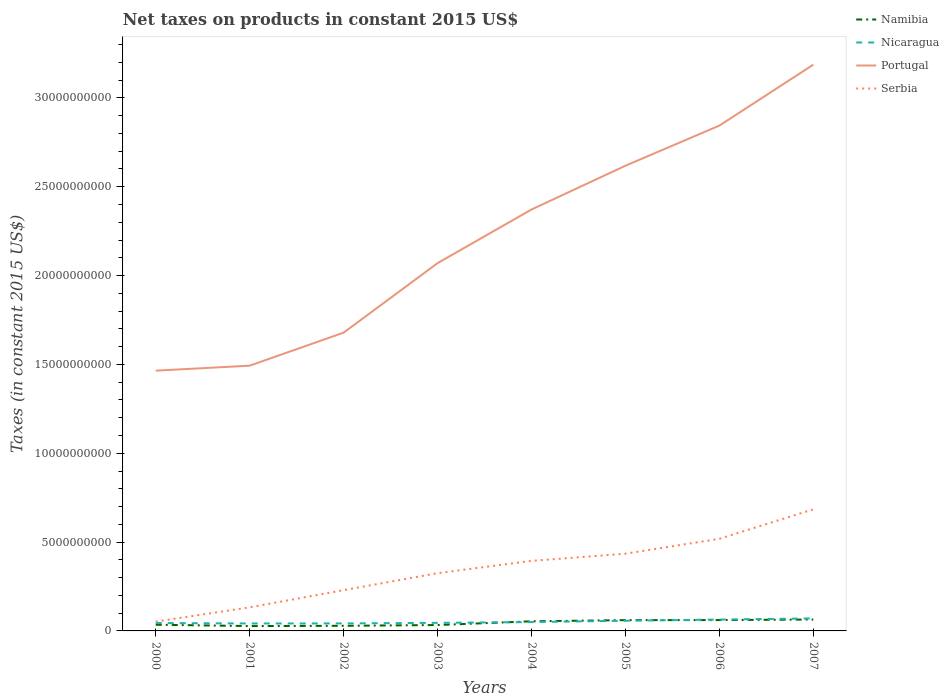How many different coloured lines are there?
Make the answer very short. 4. Is the number of lines equal to the number of legend labels?
Provide a short and direct response. Yes. Across all years, what is the maximum net taxes on products in Nicaragua?
Give a very brief answer. 4.19e+08. In which year was the net taxes on products in Namibia maximum?
Give a very brief answer. 2001. What is the total net taxes on products in Serbia in the graph?
Your answer should be compact. -1.10e+09. What is the difference between the highest and the second highest net taxes on products in Namibia?
Offer a terse response. 3.68e+08. What is the difference between the highest and the lowest net taxes on products in Nicaragua?
Provide a succinct answer. 3. What is the difference between two consecutive major ticks on the Y-axis?
Offer a terse response. 5.00e+09. Does the graph contain any zero values?
Offer a very short reply. No. Does the graph contain grids?
Your answer should be very brief. No. Where does the legend appear in the graph?
Your answer should be compact. Top right. How many legend labels are there?
Keep it short and to the point. 4. How are the legend labels stacked?
Ensure brevity in your answer.  Vertical. What is the title of the graph?
Offer a terse response. Net taxes on products in constant 2015 US$. What is the label or title of the Y-axis?
Keep it short and to the point. Taxes (in constant 2015 US$). What is the Taxes (in constant 2015 US$) of Namibia in 2000?
Ensure brevity in your answer.  3.49e+08. What is the Taxes (in constant 2015 US$) in Nicaragua in 2000?
Give a very brief answer. 4.45e+08. What is the Taxes (in constant 2015 US$) of Portugal in 2000?
Make the answer very short. 1.46e+1. What is the Taxes (in constant 2015 US$) in Serbia in 2000?
Make the answer very short. 5.25e+08. What is the Taxes (in constant 2015 US$) in Namibia in 2001?
Make the answer very short. 2.73e+08. What is the Taxes (in constant 2015 US$) in Nicaragua in 2001?
Ensure brevity in your answer.  4.19e+08. What is the Taxes (in constant 2015 US$) of Portugal in 2001?
Provide a short and direct response. 1.49e+1. What is the Taxes (in constant 2015 US$) in Serbia in 2001?
Offer a terse response. 1.33e+09. What is the Taxes (in constant 2015 US$) in Namibia in 2002?
Provide a succinct answer. 2.88e+08. What is the Taxes (in constant 2015 US$) of Nicaragua in 2002?
Offer a terse response. 4.23e+08. What is the Taxes (in constant 2015 US$) of Portugal in 2002?
Give a very brief answer. 1.68e+1. What is the Taxes (in constant 2015 US$) of Serbia in 2002?
Your answer should be very brief. 2.29e+09. What is the Taxes (in constant 2015 US$) in Namibia in 2003?
Keep it short and to the point. 3.31e+08. What is the Taxes (in constant 2015 US$) of Nicaragua in 2003?
Your answer should be compact. 4.55e+08. What is the Taxes (in constant 2015 US$) of Portugal in 2003?
Give a very brief answer. 2.07e+1. What is the Taxes (in constant 2015 US$) of Serbia in 2003?
Offer a very short reply. 3.25e+09. What is the Taxes (in constant 2015 US$) of Namibia in 2004?
Offer a terse response. 5.42e+08. What is the Taxes (in constant 2015 US$) of Nicaragua in 2004?
Your answer should be compact. 4.97e+08. What is the Taxes (in constant 2015 US$) in Portugal in 2004?
Ensure brevity in your answer.  2.37e+1. What is the Taxes (in constant 2015 US$) in Serbia in 2004?
Your response must be concise. 3.94e+09. What is the Taxes (in constant 2015 US$) in Namibia in 2005?
Offer a terse response. 6.08e+08. What is the Taxes (in constant 2015 US$) in Nicaragua in 2005?
Offer a terse response. 5.73e+08. What is the Taxes (in constant 2015 US$) in Portugal in 2005?
Ensure brevity in your answer.  2.62e+1. What is the Taxes (in constant 2015 US$) of Serbia in 2005?
Your answer should be very brief. 4.35e+09. What is the Taxes (in constant 2015 US$) of Namibia in 2006?
Make the answer very short. 6.10e+08. What is the Taxes (in constant 2015 US$) of Nicaragua in 2006?
Keep it short and to the point. 6.40e+08. What is the Taxes (in constant 2015 US$) in Portugal in 2006?
Offer a terse response. 2.84e+1. What is the Taxes (in constant 2015 US$) in Serbia in 2006?
Offer a very short reply. 5.18e+09. What is the Taxes (in constant 2015 US$) in Namibia in 2007?
Offer a very short reply. 6.42e+08. What is the Taxes (in constant 2015 US$) of Nicaragua in 2007?
Your answer should be very brief. 7.04e+08. What is the Taxes (in constant 2015 US$) of Portugal in 2007?
Your answer should be very brief. 3.19e+1. What is the Taxes (in constant 2015 US$) in Serbia in 2007?
Your response must be concise. 6.84e+09. Across all years, what is the maximum Taxes (in constant 2015 US$) of Namibia?
Give a very brief answer. 6.42e+08. Across all years, what is the maximum Taxes (in constant 2015 US$) of Nicaragua?
Your response must be concise. 7.04e+08. Across all years, what is the maximum Taxes (in constant 2015 US$) in Portugal?
Your response must be concise. 3.19e+1. Across all years, what is the maximum Taxes (in constant 2015 US$) in Serbia?
Provide a succinct answer. 6.84e+09. Across all years, what is the minimum Taxes (in constant 2015 US$) of Namibia?
Keep it short and to the point. 2.73e+08. Across all years, what is the minimum Taxes (in constant 2015 US$) in Nicaragua?
Offer a terse response. 4.19e+08. Across all years, what is the minimum Taxes (in constant 2015 US$) in Portugal?
Ensure brevity in your answer.  1.46e+1. Across all years, what is the minimum Taxes (in constant 2015 US$) of Serbia?
Your answer should be very brief. 5.25e+08. What is the total Taxes (in constant 2015 US$) of Namibia in the graph?
Offer a terse response. 3.64e+09. What is the total Taxes (in constant 2015 US$) of Nicaragua in the graph?
Make the answer very short. 4.16e+09. What is the total Taxes (in constant 2015 US$) in Portugal in the graph?
Your answer should be compact. 1.77e+11. What is the total Taxes (in constant 2015 US$) of Serbia in the graph?
Provide a short and direct response. 2.77e+1. What is the difference between the Taxes (in constant 2015 US$) of Namibia in 2000 and that in 2001?
Give a very brief answer. 7.55e+07. What is the difference between the Taxes (in constant 2015 US$) of Nicaragua in 2000 and that in 2001?
Provide a short and direct response. 2.55e+07. What is the difference between the Taxes (in constant 2015 US$) in Portugal in 2000 and that in 2001?
Your response must be concise. -2.81e+08. What is the difference between the Taxes (in constant 2015 US$) of Serbia in 2000 and that in 2001?
Your response must be concise. -8.02e+08. What is the difference between the Taxes (in constant 2015 US$) of Namibia in 2000 and that in 2002?
Ensure brevity in your answer.  6.06e+07. What is the difference between the Taxes (in constant 2015 US$) in Nicaragua in 2000 and that in 2002?
Your answer should be compact. 2.14e+07. What is the difference between the Taxes (in constant 2015 US$) in Portugal in 2000 and that in 2002?
Offer a terse response. -2.14e+09. What is the difference between the Taxes (in constant 2015 US$) in Serbia in 2000 and that in 2002?
Your response must be concise. -1.77e+09. What is the difference between the Taxes (in constant 2015 US$) of Namibia in 2000 and that in 2003?
Provide a succinct answer. 1.76e+07. What is the difference between the Taxes (in constant 2015 US$) of Nicaragua in 2000 and that in 2003?
Offer a very short reply. -9.90e+06. What is the difference between the Taxes (in constant 2015 US$) of Portugal in 2000 and that in 2003?
Ensure brevity in your answer.  -6.05e+09. What is the difference between the Taxes (in constant 2015 US$) in Serbia in 2000 and that in 2003?
Provide a short and direct response. -2.73e+09. What is the difference between the Taxes (in constant 2015 US$) of Namibia in 2000 and that in 2004?
Make the answer very short. -1.93e+08. What is the difference between the Taxes (in constant 2015 US$) in Nicaragua in 2000 and that in 2004?
Keep it short and to the point. -5.20e+07. What is the difference between the Taxes (in constant 2015 US$) of Portugal in 2000 and that in 2004?
Give a very brief answer. -9.07e+09. What is the difference between the Taxes (in constant 2015 US$) of Serbia in 2000 and that in 2004?
Make the answer very short. -3.42e+09. What is the difference between the Taxes (in constant 2015 US$) of Namibia in 2000 and that in 2005?
Provide a succinct answer. -2.59e+08. What is the difference between the Taxes (in constant 2015 US$) in Nicaragua in 2000 and that in 2005?
Keep it short and to the point. -1.28e+08. What is the difference between the Taxes (in constant 2015 US$) in Portugal in 2000 and that in 2005?
Keep it short and to the point. -1.15e+1. What is the difference between the Taxes (in constant 2015 US$) in Serbia in 2000 and that in 2005?
Offer a very short reply. -3.82e+09. What is the difference between the Taxes (in constant 2015 US$) of Namibia in 2000 and that in 2006?
Give a very brief answer. -2.62e+08. What is the difference between the Taxes (in constant 2015 US$) in Nicaragua in 2000 and that in 2006?
Make the answer very short. -1.96e+08. What is the difference between the Taxes (in constant 2015 US$) of Portugal in 2000 and that in 2006?
Provide a short and direct response. -1.38e+1. What is the difference between the Taxes (in constant 2015 US$) in Serbia in 2000 and that in 2006?
Keep it short and to the point. -4.66e+09. What is the difference between the Taxes (in constant 2015 US$) of Namibia in 2000 and that in 2007?
Give a very brief answer. -2.93e+08. What is the difference between the Taxes (in constant 2015 US$) of Nicaragua in 2000 and that in 2007?
Offer a very short reply. -2.59e+08. What is the difference between the Taxes (in constant 2015 US$) of Portugal in 2000 and that in 2007?
Make the answer very short. -1.72e+1. What is the difference between the Taxes (in constant 2015 US$) of Serbia in 2000 and that in 2007?
Your response must be concise. -6.32e+09. What is the difference between the Taxes (in constant 2015 US$) in Namibia in 2001 and that in 2002?
Ensure brevity in your answer.  -1.49e+07. What is the difference between the Taxes (in constant 2015 US$) in Nicaragua in 2001 and that in 2002?
Offer a terse response. -4.11e+06. What is the difference between the Taxes (in constant 2015 US$) in Portugal in 2001 and that in 2002?
Give a very brief answer. -1.86e+09. What is the difference between the Taxes (in constant 2015 US$) in Serbia in 2001 and that in 2002?
Provide a short and direct response. -9.67e+08. What is the difference between the Taxes (in constant 2015 US$) in Namibia in 2001 and that in 2003?
Provide a succinct answer. -5.79e+07. What is the difference between the Taxes (in constant 2015 US$) of Nicaragua in 2001 and that in 2003?
Ensure brevity in your answer.  -3.54e+07. What is the difference between the Taxes (in constant 2015 US$) in Portugal in 2001 and that in 2003?
Keep it short and to the point. -5.77e+09. What is the difference between the Taxes (in constant 2015 US$) in Serbia in 2001 and that in 2003?
Offer a terse response. -1.92e+09. What is the difference between the Taxes (in constant 2015 US$) in Namibia in 2001 and that in 2004?
Your answer should be compact. -2.69e+08. What is the difference between the Taxes (in constant 2015 US$) in Nicaragua in 2001 and that in 2004?
Offer a terse response. -7.75e+07. What is the difference between the Taxes (in constant 2015 US$) in Portugal in 2001 and that in 2004?
Your answer should be very brief. -8.79e+09. What is the difference between the Taxes (in constant 2015 US$) of Serbia in 2001 and that in 2004?
Provide a short and direct response. -2.62e+09. What is the difference between the Taxes (in constant 2015 US$) of Namibia in 2001 and that in 2005?
Your answer should be compact. -3.34e+08. What is the difference between the Taxes (in constant 2015 US$) in Nicaragua in 2001 and that in 2005?
Offer a terse response. -1.54e+08. What is the difference between the Taxes (in constant 2015 US$) in Portugal in 2001 and that in 2005?
Provide a short and direct response. -1.13e+1. What is the difference between the Taxes (in constant 2015 US$) of Serbia in 2001 and that in 2005?
Offer a terse response. -3.02e+09. What is the difference between the Taxes (in constant 2015 US$) in Namibia in 2001 and that in 2006?
Provide a short and direct response. -3.37e+08. What is the difference between the Taxes (in constant 2015 US$) of Nicaragua in 2001 and that in 2006?
Provide a short and direct response. -2.21e+08. What is the difference between the Taxes (in constant 2015 US$) in Portugal in 2001 and that in 2006?
Offer a very short reply. -1.35e+1. What is the difference between the Taxes (in constant 2015 US$) in Serbia in 2001 and that in 2006?
Make the answer very short. -3.86e+09. What is the difference between the Taxes (in constant 2015 US$) in Namibia in 2001 and that in 2007?
Provide a short and direct response. -3.68e+08. What is the difference between the Taxes (in constant 2015 US$) of Nicaragua in 2001 and that in 2007?
Offer a terse response. -2.85e+08. What is the difference between the Taxes (in constant 2015 US$) of Portugal in 2001 and that in 2007?
Offer a terse response. -1.69e+1. What is the difference between the Taxes (in constant 2015 US$) in Serbia in 2001 and that in 2007?
Offer a terse response. -5.52e+09. What is the difference between the Taxes (in constant 2015 US$) of Namibia in 2002 and that in 2003?
Give a very brief answer. -4.30e+07. What is the difference between the Taxes (in constant 2015 US$) of Nicaragua in 2002 and that in 2003?
Provide a short and direct response. -3.13e+07. What is the difference between the Taxes (in constant 2015 US$) of Portugal in 2002 and that in 2003?
Give a very brief answer. -3.91e+09. What is the difference between the Taxes (in constant 2015 US$) of Serbia in 2002 and that in 2003?
Provide a succinct answer. -9.57e+08. What is the difference between the Taxes (in constant 2015 US$) in Namibia in 2002 and that in 2004?
Offer a very short reply. -2.54e+08. What is the difference between the Taxes (in constant 2015 US$) of Nicaragua in 2002 and that in 2004?
Offer a very short reply. -7.34e+07. What is the difference between the Taxes (in constant 2015 US$) in Portugal in 2002 and that in 2004?
Offer a very short reply. -6.93e+09. What is the difference between the Taxes (in constant 2015 US$) in Serbia in 2002 and that in 2004?
Your answer should be compact. -1.65e+09. What is the difference between the Taxes (in constant 2015 US$) in Namibia in 2002 and that in 2005?
Your answer should be compact. -3.19e+08. What is the difference between the Taxes (in constant 2015 US$) in Nicaragua in 2002 and that in 2005?
Offer a very short reply. -1.50e+08. What is the difference between the Taxes (in constant 2015 US$) in Portugal in 2002 and that in 2005?
Make the answer very short. -9.39e+09. What is the difference between the Taxes (in constant 2015 US$) of Serbia in 2002 and that in 2005?
Provide a short and direct response. -2.05e+09. What is the difference between the Taxes (in constant 2015 US$) of Namibia in 2002 and that in 2006?
Keep it short and to the point. -3.22e+08. What is the difference between the Taxes (in constant 2015 US$) in Nicaragua in 2002 and that in 2006?
Your answer should be compact. -2.17e+08. What is the difference between the Taxes (in constant 2015 US$) of Portugal in 2002 and that in 2006?
Your answer should be very brief. -1.17e+1. What is the difference between the Taxes (in constant 2015 US$) in Serbia in 2002 and that in 2006?
Your response must be concise. -2.89e+09. What is the difference between the Taxes (in constant 2015 US$) in Namibia in 2002 and that in 2007?
Make the answer very short. -3.54e+08. What is the difference between the Taxes (in constant 2015 US$) of Nicaragua in 2002 and that in 2007?
Provide a succinct answer. -2.81e+08. What is the difference between the Taxes (in constant 2015 US$) in Portugal in 2002 and that in 2007?
Your response must be concise. -1.51e+1. What is the difference between the Taxes (in constant 2015 US$) of Serbia in 2002 and that in 2007?
Keep it short and to the point. -4.55e+09. What is the difference between the Taxes (in constant 2015 US$) of Namibia in 2003 and that in 2004?
Ensure brevity in your answer.  -2.11e+08. What is the difference between the Taxes (in constant 2015 US$) of Nicaragua in 2003 and that in 2004?
Ensure brevity in your answer.  -4.21e+07. What is the difference between the Taxes (in constant 2015 US$) of Portugal in 2003 and that in 2004?
Your response must be concise. -3.02e+09. What is the difference between the Taxes (in constant 2015 US$) of Serbia in 2003 and that in 2004?
Offer a terse response. -6.91e+08. What is the difference between the Taxes (in constant 2015 US$) of Namibia in 2003 and that in 2005?
Offer a very short reply. -2.76e+08. What is the difference between the Taxes (in constant 2015 US$) in Nicaragua in 2003 and that in 2005?
Give a very brief answer. -1.18e+08. What is the difference between the Taxes (in constant 2015 US$) of Portugal in 2003 and that in 2005?
Ensure brevity in your answer.  -5.48e+09. What is the difference between the Taxes (in constant 2015 US$) in Serbia in 2003 and that in 2005?
Provide a short and direct response. -1.10e+09. What is the difference between the Taxes (in constant 2015 US$) of Namibia in 2003 and that in 2006?
Provide a short and direct response. -2.79e+08. What is the difference between the Taxes (in constant 2015 US$) of Nicaragua in 2003 and that in 2006?
Ensure brevity in your answer.  -1.86e+08. What is the difference between the Taxes (in constant 2015 US$) in Portugal in 2003 and that in 2006?
Provide a succinct answer. -7.74e+09. What is the difference between the Taxes (in constant 2015 US$) in Serbia in 2003 and that in 2006?
Ensure brevity in your answer.  -1.93e+09. What is the difference between the Taxes (in constant 2015 US$) in Namibia in 2003 and that in 2007?
Keep it short and to the point. -3.11e+08. What is the difference between the Taxes (in constant 2015 US$) in Nicaragua in 2003 and that in 2007?
Ensure brevity in your answer.  -2.49e+08. What is the difference between the Taxes (in constant 2015 US$) of Portugal in 2003 and that in 2007?
Offer a terse response. -1.12e+1. What is the difference between the Taxes (in constant 2015 US$) of Serbia in 2003 and that in 2007?
Ensure brevity in your answer.  -3.59e+09. What is the difference between the Taxes (in constant 2015 US$) in Namibia in 2004 and that in 2005?
Make the answer very short. -6.54e+07. What is the difference between the Taxes (in constant 2015 US$) in Nicaragua in 2004 and that in 2005?
Your response must be concise. -7.62e+07. What is the difference between the Taxes (in constant 2015 US$) of Portugal in 2004 and that in 2005?
Ensure brevity in your answer.  -2.47e+09. What is the difference between the Taxes (in constant 2015 US$) of Serbia in 2004 and that in 2005?
Ensure brevity in your answer.  -4.05e+08. What is the difference between the Taxes (in constant 2015 US$) of Namibia in 2004 and that in 2006?
Offer a very short reply. -6.82e+07. What is the difference between the Taxes (in constant 2015 US$) of Nicaragua in 2004 and that in 2006?
Give a very brief answer. -1.43e+08. What is the difference between the Taxes (in constant 2015 US$) in Portugal in 2004 and that in 2006?
Provide a short and direct response. -4.72e+09. What is the difference between the Taxes (in constant 2015 US$) in Serbia in 2004 and that in 2006?
Offer a very short reply. -1.24e+09. What is the difference between the Taxes (in constant 2015 US$) of Namibia in 2004 and that in 2007?
Provide a succinct answer. -9.96e+07. What is the difference between the Taxes (in constant 2015 US$) in Nicaragua in 2004 and that in 2007?
Ensure brevity in your answer.  -2.07e+08. What is the difference between the Taxes (in constant 2015 US$) in Portugal in 2004 and that in 2007?
Your answer should be compact. -8.15e+09. What is the difference between the Taxes (in constant 2015 US$) of Serbia in 2004 and that in 2007?
Offer a very short reply. -2.90e+09. What is the difference between the Taxes (in constant 2015 US$) of Namibia in 2005 and that in 2006?
Your response must be concise. -2.85e+06. What is the difference between the Taxes (in constant 2015 US$) in Nicaragua in 2005 and that in 2006?
Offer a very short reply. -6.73e+07. What is the difference between the Taxes (in constant 2015 US$) in Portugal in 2005 and that in 2006?
Provide a succinct answer. -2.26e+09. What is the difference between the Taxes (in constant 2015 US$) of Serbia in 2005 and that in 2006?
Provide a short and direct response. -8.37e+08. What is the difference between the Taxes (in constant 2015 US$) in Namibia in 2005 and that in 2007?
Ensure brevity in your answer.  -3.43e+07. What is the difference between the Taxes (in constant 2015 US$) of Nicaragua in 2005 and that in 2007?
Give a very brief answer. -1.31e+08. What is the difference between the Taxes (in constant 2015 US$) in Portugal in 2005 and that in 2007?
Your response must be concise. -5.69e+09. What is the difference between the Taxes (in constant 2015 US$) in Serbia in 2005 and that in 2007?
Provide a succinct answer. -2.50e+09. What is the difference between the Taxes (in constant 2015 US$) of Namibia in 2006 and that in 2007?
Offer a very short reply. -3.14e+07. What is the difference between the Taxes (in constant 2015 US$) of Nicaragua in 2006 and that in 2007?
Keep it short and to the point. -6.38e+07. What is the difference between the Taxes (in constant 2015 US$) of Portugal in 2006 and that in 2007?
Provide a succinct answer. -3.43e+09. What is the difference between the Taxes (in constant 2015 US$) of Serbia in 2006 and that in 2007?
Ensure brevity in your answer.  -1.66e+09. What is the difference between the Taxes (in constant 2015 US$) of Namibia in 2000 and the Taxes (in constant 2015 US$) of Nicaragua in 2001?
Offer a very short reply. -7.03e+07. What is the difference between the Taxes (in constant 2015 US$) in Namibia in 2000 and the Taxes (in constant 2015 US$) in Portugal in 2001?
Offer a very short reply. -1.46e+1. What is the difference between the Taxes (in constant 2015 US$) in Namibia in 2000 and the Taxes (in constant 2015 US$) in Serbia in 2001?
Offer a very short reply. -9.78e+08. What is the difference between the Taxes (in constant 2015 US$) in Nicaragua in 2000 and the Taxes (in constant 2015 US$) in Portugal in 2001?
Provide a short and direct response. -1.45e+1. What is the difference between the Taxes (in constant 2015 US$) in Nicaragua in 2000 and the Taxes (in constant 2015 US$) in Serbia in 2001?
Make the answer very short. -8.82e+08. What is the difference between the Taxes (in constant 2015 US$) of Portugal in 2000 and the Taxes (in constant 2015 US$) of Serbia in 2001?
Offer a terse response. 1.33e+1. What is the difference between the Taxes (in constant 2015 US$) in Namibia in 2000 and the Taxes (in constant 2015 US$) in Nicaragua in 2002?
Your answer should be compact. -7.44e+07. What is the difference between the Taxes (in constant 2015 US$) of Namibia in 2000 and the Taxes (in constant 2015 US$) of Portugal in 2002?
Your answer should be compact. -1.64e+1. What is the difference between the Taxes (in constant 2015 US$) of Namibia in 2000 and the Taxes (in constant 2015 US$) of Serbia in 2002?
Your answer should be very brief. -1.95e+09. What is the difference between the Taxes (in constant 2015 US$) in Nicaragua in 2000 and the Taxes (in constant 2015 US$) in Portugal in 2002?
Offer a terse response. -1.63e+1. What is the difference between the Taxes (in constant 2015 US$) of Nicaragua in 2000 and the Taxes (in constant 2015 US$) of Serbia in 2002?
Provide a short and direct response. -1.85e+09. What is the difference between the Taxes (in constant 2015 US$) of Portugal in 2000 and the Taxes (in constant 2015 US$) of Serbia in 2002?
Your answer should be compact. 1.24e+1. What is the difference between the Taxes (in constant 2015 US$) in Namibia in 2000 and the Taxes (in constant 2015 US$) in Nicaragua in 2003?
Offer a terse response. -1.06e+08. What is the difference between the Taxes (in constant 2015 US$) in Namibia in 2000 and the Taxes (in constant 2015 US$) in Portugal in 2003?
Offer a terse response. -2.04e+1. What is the difference between the Taxes (in constant 2015 US$) of Namibia in 2000 and the Taxes (in constant 2015 US$) of Serbia in 2003?
Your answer should be very brief. -2.90e+09. What is the difference between the Taxes (in constant 2015 US$) of Nicaragua in 2000 and the Taxes (in constant 2015 US$) of Portugal in 2003?
Provide a short and direct response. -2.03e+1. What is the difference between the Taxes (in constant 2015 US$) of Nicaragua in 2000 and the Taxes (in constant 2015 US$) of Serbia in 2003?
Your response must be concise. -2.81e+09. What is the difference between the Taxes (in constant 2015 US$) in Portugal in 2000 and the Taxes (in constant 2015 US$) in Serbia in 2003?
Offer a very short reply. 1.14e+1. What is the difference between the Taxes (in constant 2015 US$) of Namibia in 2000 and the Taxes (in constant 2015 US$) of Nicaragua in 2004?
Make the answer very short. -1.48e+08. What is the difference between the Taxes (in constant 2015 US$) in Namibia in 2000 and the Taxes (in constant 2015 US$) in Portugal in 2004?
Your answer should be very brief. -2.34e+1. What is the difference between the Taxes (in constant 2015 US$) in Namibia in 2000 and the Taxes (in constant 2015 US$) in Serbia in 2004?
Your response must be concise. -3.59e+09. What is the difference between the Taxes (in constant 2015 US$) in Nicaragua in 2000 and the Taxes (in constant 2015 US$) in Portugal in 2004?
Your answer should be compact. -2.33e+1. What is the difference between the Taxes (in constant 2015 US$) of Nicaragua in 2000 and the Taxes (in constant 2015 US$) of Serbia in 2004?
Offer a very short reply. -3.50e+09. What is the difference between the Taxes (in constant 2015 US$) in Portugal in 2000 and the Taxes (in constant 2015 US$) in Serbia in 2004?
Keep it short and to the point. 1.07e+1. What is the difference between the Taxes (in constant 2015 US$) in Namibia in 2000 and the Taxes (in constant 2015 US$) in Nicaragua in 2005?
Your answer should be very brief. -2.24e+08. What is the difference between the Taxes (in constant 2015 US$) of Namibia in 2000 and the Taxes (in constant 2015 US$) of Portugal in 2005?
Your response must be concise. -2.58e+1. What is the difference between the Taxes (in constant 2015 US$) of Namibia in 2000 and the Taxes (in constant 2015 US$) of Serbia in 2005?
Offer a terse response. -4.00e+09. What is the difference between the Taxes (in constant 2015 US$) in Nicaragua in 2000 and the Taxes (in constant 2015 US$) in Portugal in 2005?
Offer a very short reply. -2.57e+1. What is the difference between the Taxes (in constant 2015 US$) of Nicaragua in 2000 and the Taxes (in constant 2015 US$) of Serbia in 2005?
Offer a terse response. -3.90e+09. What is the difference between the Taxes (in constant 2015 US$) in Portugal in 2000 and the Taxes (in constant 2015 US$) in Serbia in 2005?
Offer a very short reply. 1.03e+1. What is the difference between the Taxes (in constant 2015 US$) in Namibia in 2000 and the Taxes (in constant 2015 US$) in Nicaragua in 2006?
Your answer should be very brief. -2.91e+08. What is the difference between the Taxes (in constant 2015 US$) in Namibia in 2000 and the Taxes (in constant 2015 US$) in Portugal in 2006?
Offer a terse response. -2.81e+1. What is the difference between the Taxes (in constant 2015 US$) of Namibia in 2000 and the Taxes (in constant 2015 US$) of Serbia in 2006?
Your answer should be very brief. -4.84e+09. What is the difference between the Taxes (in constant 2015 US$) in Nicaragua in 2000 and the Taxes (in constant 2015 US$) in Portugal in 2006?
Your answer should be compact. -2.80e+1. What is the difference between the Taxes (in constant 2015 US$) of Nicaragua in 2000 and the Taxes (in constant 2015 US$) of Serbia in 2006?
Make the answer very short. -4.74e+09. What is the difference between the Taxes (in constant 2015 US$) in Portugal in 2000 and the Taxes (in constant 2015 US$) in Serbia in 2006?
Provide a short and direct response. 9.46e+09. What is the difference between the Taxes (in constant 2015 US$) in Namibia in 2000 and the Taxes (in constant 2015 US$) in Nicaragua in 2007?
Provide a short and direct response. -3.55e+08. What is the difference between the Taxes (in constant 2015 US$) of Namibia in 2000 and the Taxes (in constant 2015 US$) of Portugal in 2007?
Ensure brevity in your answer.  -3.15e+1. What is the difference between the Taxes (in constant 2015 US$) of Namibia in 2000 and the Taxes (in constant 2015 US$) of Serbia in 2007?
Provide a short and direct response. -6.50e+09. What is the difference between the Taxes (in constant 2015 US$) in Nicaragua in 2000 and the Taxes (in constant 2015 US$) in Portugal in 2007?
Provide a short and direct response. -3.14e+1. What is the difference between the Taxes (in constant 2015 US$) in Nicaragua in 2000 and the Taxes (in constant 2015 US$) in Serbia in 2007?
Your answer should be very brief. -6.40e+09. What is the difference between the Taxes (in constant 2015 US$) of Portugal in 2000 and the Taxes (in constant 2015 US$) of Serbia in 2007?
Your answer should be very brief. 7.80e+09. What is the difference between the Taxes (in constant 2015 US$) of Namibia in 2001 and the Taxes (in constant 2015 US$) of Nicaragua in 2002?
Your response must be concise. -1.50e+08. What is the difference between the Taxes (in constant 2015 US$) of Namibia in 2001 and the Taxes (in constant 2015 US$) of Portugal in 2002?
Offer a terse response. -1.65e+1. What is the difference between the Taxes (in constant 2015 US$) of Namibia in 2001 and the Taxes (in constant 2015 US$) of Serbia in 2002?
Your response must be concise. -2.02e+09. What is the difference between the Taxes (in constant 2015 US$) of Nicaragua in 2001 and the Taxes (in constant 2015 US$) of Portugal in 2002?
Give a very brief answer. -1.64e+1. What is the difference between the Taxes (in constant 2015 US$) of Nicaragua in 2001 and the Taxes (in constant 2015 US$) of Serbia in 2002?
Make the answer very short. -1.88e+09. What is the difference between the Taxes (in constant 2015 US$) of Portugal in 2001 and the Taxes (in constant 2015 US$) of Serbia in 2002?
Provide a succinct answer. 1.26e+1. What is the difference between the Taxes (in constant 2015 US$) of Namibia in 2001 and the Taxes (in constant 2015 US$) of Nicaragua in 2003?
Your answer should be very brief. -1.81e+08. What is the difference between the Taxes (in constant 2015 US$) in Namibia in 2001 and the Taxes (in constant 2015 US$) in Portugal in 2003?
Keep it short and to the point. -2.04e+1. What is the difference between the Taxes (in constant 2015 US$) in Namibia in 2001 and the Taxes (in constant 2015 US$) in Serbia in 2003?
Give a very brief answer. -2.98e+09. What is the difference between the Taxes (in constant 2015 US$) in Nicaragua in 2001 and the Taxes (in constant 2015 US$) in Portugal in 2003?
Offer a terse response. -2.03e+1. What is the difference between the Taxes (in constant 2015 US$) of Nicaragua in 2001 and the Taxes (in constant 2015 US$) of Serbia in 2003?
Provide a short and direct response. -2.83e+09. What is the difference between the Taxes (in constant 2015 US$) of Portugal in 2001 and the Taxes (in constant 2015 US$) of Serbia in 2003?
Make the answer very short. 1.17e+1. What is the difference between the Taxes (in constant 2015 US$) in Namibia in 2001 and the Taxes (in constant 2015 US$) in Nicaragua in 2004?
Offer a terse response. -2.23e+08. What is the difference between the Taxes (in constant 2015 US$) of Namibia in 2001 and the Taxes (in constant 2015 US$) of Portugal in 2004?
Your response must be concise. -2.34e+1. What is the difference between the Taxes (in constant 2015 US$) in Namibia in 2001 and the Taxes (in constant 2015 US$) in Serbia in 2004?
Give a very brief answer. -3.67e+09. What is the difference between the Taxes (in constant 2015 US$) of Nicaragua in 2001 and the Taxes (in constant 2015 US$) of Portugal in 2004?
Your answer should be compact. -2.33e+1. What is the difference between the Taxes (in constant 2015 US$) in Nicaragua in 2001 and the Taxes (in constant 2015 US$) in Serbia in 2004?
Keep it short and to the point. -3.52e+09. What is the difference between the Taxes (in constant 2015 US$) in Portugal in 2001 and the Taxes (in constant 2015 US$) in Serbia in 2004?
Your answer should be compact. 1.10e+1. What is the difference between the Taxes (in constant 2015 US$) of Namibia in 2001 and the Taxes (in constant 2015 US$) of Nicaragua in 2005?
Offer a very short reply. -3.00e+08. What is the difference between the Taxes (in constant 2015 US$) in Namibia in 2001 and the Taxes (in constant 2015 US$) in Portugal in 2005?
Your answer should be compact. -2.59e+1. What is the difference between the Taxes (in constant 2015 US$) in Namibia in 2001 and the Taxes (in constant 2015 US$) in Serbia in 2005?
Give a very brief answer. -4.07e+09. What is the difference between the Taxes (in constant 2015 US$) in Nicaragua in 2001 and the Taxes (in constant 2015 US$) in Portugal in 2005?
Your response must be concise. -2.58e+1. What is the difference between the Taxes (in constant 2015 US$) of Nicaragua in 2001 and the Taxes (in constant 2015 US$) of Serbia in 2005?
Your answer should be very brief. -3.93e+09. What is the difference between the Taxes (in constant 2015 US$) in Portugal in 2001 and the Taxes (in constant 2015 US$) in Serbia in 2005?
Keep it short and to the point. 1.06e+1. What is the difference between the Taxes (in constant 2015 US$) of Namibia in 2001 and the Taxes (in constant 2015 US$) of Nicaragua in 2006?
Provide a succinct answer. -3.67e+08. What is the difference between the Taxes (in constant 2015 US$) of Namibia in 2001 and the Taxes (in constant 2015 US$) of Portugal in 2006?
Your answer should be very brief. -2.82e+1. What is the difference between the Taxes (in constant 2015 US$) of Namibia in 2001 and the Taxes (in constant 2015 US$) of Serbia in 2006?
Your response must be concise. -4.91e+09. What is the difference between the Taxes (in constant 2015 US$) in Nicaragua in 2001 and the Taxes (in constant 2015 US$) in Portugal in 2006?
Your answer should be very brief. -2.80e+1. What is the difference between the Taxes (in constant 2015 US$) in Nicaragua in 2001 and the Taxes (in constant 2015 US$) in Serbia in 2006?
Provide a succinct answer. -4.77e+09. What is the difference between the Taxes (in constant 2015 US$) in Portugal in 2001 and the Taxes (in constant 2015 US$) in Serbia in 2006?
Make the answer very short. 9.74e+09. What is the difference between the Taxes (in constant 2015 US$) of Namibia in 2001 and the Taxes (in constant 2015 US$) of Nicaragua in 2007?
Your response must be concise. -4.31e+08. What is the difference between the Taxes (in constant 2015 US$) of Namibia in 2001 and the Taxes (in constant 2015 US$) of Portugal in 2007?
Ensure brevity in your answer.  -3.16e+1. What is the difference between the Taxes (in constant 2015 US$) in Namibia in 2001 and the Taxes (in constant 2015 US$) in Serbia in 2007?
Your answer should be very brief. -6.57e+09. What is the difference between the Taxes (in constant 2015 US$) of Nicaragua in 2001 and the Taxes (in constant 2015 US$) of Portugal in 2007?
Offer a very short reply. -3.15e+1. What is the difference between the Taxes (in constant 2015 US$) in Nicaragua in 2001 and the Taxes (in constant 2015 US$) in Serbia in 2007?
Keep it short and to the point. -6.43e+09. What is the difference between the Taxes (in constant 2015 US$) of Portugal in 2001 and the Taxes (in constant 2015 US$) of Serbia in 2007?
Keep it short and to the point. 8.08e+09. What is the difference between the Taxes (in constant 2015 US$) of Namibia in 2002 and the Taxes (in constant 2015 US$) of Nicaragua in 2003?
Make the answer very short. -1.66e+08. What is the difference between the Taxes (in constant 2015 US$) of Namibia in 2002 and the Taxes (in constant 2015 US$) of Portugal in 2003?
Offer a very short reply. -2.04e+1. What is the difference between the Taxes (in constant 2015 US$) in Namibia in 2002 and the Taxes (in constant 2015 US$) in Serbia in 2003?
Your response must be concise. -2.96e+09. What is the difference between the Taxes (in constant 2015 US$) in Nicaragua in 2002 and the Taxes (in constant 2015 US$) in Portugal in 2003?
Offer a terse response. -2.03e+1. What is the difference between the Taxes (in constant 2015 US$) in Nicaragua in 2002 and the Taxes (in constant 2015 US$) in Serbia in 2003?
Your response must be concise. -2.83e+09. What is the difference between the Taxes (in constant 2015 US$) in Portugal in 2002 and the Taxes (in constant 2015 US$) in Serbia in 2003?
Ensure brevity in your answer.  1.35e+1. What is the difference between the Taxes (in constant 2015 US$) of Namibia in 2002 and the Taxes (in constant 2015 US$) of Nicaragua in 2004?
Keep it short and to the point. -2.08e+08. What is the difference between the Taxes (in constant 2015 US$) of Namibia in 2002 and the Taxes (in constant 2015 US$) of Portugal in 2004?
Give a very brief answer. -2.34e+1. What is the difference between the Taxes (in constant 2015 US$) in Namibia in 2002 and the Taxes (in constant 2015 US$) in Serbia in 2004?
Provide a short and direct response. -3.65e+09. What is the difference between the Taxes (in constant 2015 US$) of Nicaragua in 2002 and the Taxes (in constant 2015 US$) of Portugal in 2004?
Ensure brevity in your answer.  -2.33e+1. What is the difference between the Taxes (in constant 2015 US$) in Nicaragua in 2002 and the Taxes (in constant 2015 US$) in Serbia in 2004?
Your answer should be compact. -3.52e+09. What is the difference between the Taxes (in constant 2015 US$) of Portugal in 2002 and the Taxes (in constant 2015 US$) of Serbia in 2004?
Offer a very short reply. 1.28e+1. What is the difference between the Taxes (in constant 2015 US$) of Namibia in 2002 and the Taxes (in constant 2015 US$) of Nicaragua in 2005?
Provide a short and direct response. -2.85e+08. What is the difference between the Taxes (in constant 2015 US$) in Namibia in 2002 and the Taxes (in constant 2015 US$) in Portugal in 2005?
Offer a terse response. -2.59e+1. What is the difference between the Taxes (in constant 2015 US$) in Namibia in 2002 and the Taxes (in constant 2015 US$) in Serbia in 2005?
Your answer should be very brief. -4.06e+09. What is the difference between the Taxes (in constant 2015 US$) in Nicaragua in 2002 and the Taxes (in constant 2015 US$) in Portugal in 2005?
Your answer should be very brief. -2.58e+1. What is the difference between the Taxes (in constant 2015 US$) of Nicaragua in 2002 and the Taxes (in constant 2015 US$) of Serbia in 2005?
Offer a terse response. -3.92e+09. What is the difference between the Taxes (in constant 2015 US$) of Portugal in 2002 and the Taxes (in constant 2015 US$) of Serbia in 2005?
Make the answer very short. 1.24e+1. What is the difference between the Taxes (in constant 2015 US$) of Namibia in 2002 and the Taxes (in constant 2015 US$) of Nicaragua in 2006?
Offer a terse response. -3.52e+08. What is the difference between the Taxes (in constant 2015 US$) of Namibia in 2002 and the Taxes (in constant 2015 US$) of Portugal in 2006?
Offer a very short reply. -2.82e+1. What is the difference between the Taxes (in constant 2015 US$) of Namibia in 2002 and the Taxes (in constant 2015 US$) of Serbia in 2006?
Keep it short and to the point. -4.90e+09. What is the difference between the Taxes (in constant 2015 US$) of Nicaragua in 2002 and the Taxes (in constant 2015 US$) of Portugal in 2006?
Your response must be concise. -2.80e+1. What is the difference between the Taxes (in constant 2015 US$) in Nicaragua in 2002 and the Taxes (in constant 2015 US$) in Serbia in 2006?
Your answer should be compact. -4.76e+09. What is the difference between the Taxes (in constant 2015 US$) of Portugal in 2002 and the Taxes (in constant 2015 US$) of Serbia in 2006?
Make the answer very short. 1.16e+1. What is the difference between the Taxes (in constant 2015 US$) in Namibia in 2002 and the Taxes (in constant 2015 US$) in Nicaragua in 2007?
Ensure brevity in your answer.  -4.16e+08. What is the difference between the Taxes (in constant 2015 US$) in Namibia in 2002 and the Taxes (in constant 2015 US$) in Portugal in 2007?
Ensure brevity in your answer.  -3.16e+1. What is the difference between the Taxes (in constant 2015 US$) of Namibia in 2002 and the Taxes (in constant 2015 US$) of Serbia in 2007?
Keep it short and to the point. -6.56e+09. What is the difference between the Taxes (in constant 2015 US$) in Nicaragua in 2002 and the Taxes (in constant 2015 US$) in Portugal in 2007?
Provide a succinct answer. -3.14e+1. What is the difference between the Taxes (in constant 2015 US$) of Nicaragua in 2002 and the Taxes (in constant 2015 US$) of Serbia in 2007?
Give a very brief answer. -6.42e+09. What is the difference between the Taxes (in constant 2015 US$) in Portugal in 2002 and the Taxes (in constant 2015 US$) in Serbia in 2007?
Offer a very short reply. 9.94e+09. What is the difference between the Taxes (in constant 2015 US$) of Namibia in 2003 and the Taxes (in constant 2015 US$) of Nicaragua in 2004?
Make the answer very short. -1.65e+08. What is the difference between the Taxes (in constant 2015 US$) of Namibia in 2003 and the Taxes (in constant 2015 US$) of Portugal in 2004?
Ensure brevity in your answer.  -2.34e+1. What is the difference between the Taxes (in constant 2015 US$) in Namibia in 2003 and the Taxes (in constant 2015 US$) in Serbia in 2004?
Your answer should be very brief. -3.61e+09. What is the difference between the Taxes (in constant 2015 US$) in Nicaragua in 2003 and the Taxes (in constant 2015 US$) in Portugal in 2004?
Provide a succinct answer. -2.33e+1. What is the difference between the Taxes (in constant 2015 US$) of Nicaragua in 2003 and the Taxes (in constant 2015 US$) of Serbia in 2004?
Offer a very short reply. -3.49e+09. What is the difference between the Taxes (in constant 2015 US$) in Portugal in 2003 and the Taxes (in constant 2015 US$) in Serbia in 2004?
Provide a short and direct response. 1.68e+1. What is the difference between the Taxes (in constant 2015 US$) in Namibia in 2003 and the Taxes (in constant 2015 US$) in Nicaragua in 2005?
Offer a terse response. -2.42e+08. What is the difference between the Taxes (in constant 2015 US$) of Namibia in 2003 and the Taxes (in constant 2015 US$) of Portugal in 2005?
Make the answer very short. -2.59e+1. What is the difference between the Taxes (in constant 2015 US$) of Namibia in 2003 and the Taxes (in constant 2015 US$) of Serbia in 2005?
Keep it short and to the point. -4.02e+09. What is the difference between the Taxes (in constant 2015 US$) of Nicaragua in 2003 and the Taxes (in constant 2015 US$) of Portugal in 2005?
Give a very brief answer. -2.57e+1. What is the difference between the Taxes (in constant 2015 US$) in Nicaragua in 2003 and the Taxes (in constant 2015 US$) in Serbia in 2005?
Ensure brevity in your answer.  -3.89e+09. What is the difference between the Taxes (in constant 2015 US$) in Portugal in 2003 and the Taxes (in constant 2015 US$) in Serbia in 2005?
Your answer should be compact. 1.64e+1. What is the difference between the Taxes (in constant 2015 US$) in Namibia in 2003 and the Taxes (in constant 2015 US$) in Nicaragua in 2006?
Ensure brevity in your answer.  -3.09e+08. What is the difference between the Taxes (in constant 2015 US$) of Namibia in 2003 and the Taxes (in constant 2015 US$) of Portugal in 2006?
Your answer should be compact. -2.81e+1. What is the difference between the Taxes (in constant 2015 US$) in Namibia in 2003 and the Taxes (in constant 2015 US$) in Serbia in 2006?
Your answer should be very brief. -4.85e+09. What is the difference between the Taxes (in constant 2015 US$) in Nicaragua in 2003 and the Taxes (in constant 2015 US$) in Portugal in 2006?
Make the answer very short. -2.80e+1. What is the difference between the Taxes (in constant 2015 US$) of Nicaragua in 2003 and the Taxes (in constant 2015 US$) of Serbia in 2006?
Offer a terse response. -4.73e+09. What is the difference between the Taxes (in constant 2015 US$) in Portugal in 2003 and the Taxes (in constant 2015 US$) in Serbia in 2006?
Offer a terse response. 1.55e+1. What is the difference between the Taxes (in constant 2015 US$) in Namibia in 2003 and the Taxes (in constant 2015 US$) in Nicaragua in 2007?
Provide a short and direct response. -3.73e+08. What is the difference between the Taxes (in constant 2015 US$) in Namibia in 2003 and the Taxes (in constant 2015 US$) in Portugal in 2007?
Your response must be concise. -3.15e+1. What is the difference between the Taxes (in constant 2015 US$) in Namibia in 2003 and the Taxes (in constant 2015 US$) in Serbia in 2007?
Your answer should be very brief. -6.51e+09. What is the difference between the Taxes (in constant 2015 US$) of Nicaragua in 2003 and the Taxes (in constant 2015 US$) of Portugal in 2007?
Offer a terse response. -3.14e+1. What is the difference between the Taxes (in constant 2015 US$) of Nicaragua in 2003 and the Taxes (in constant 2015 US$) of Serbia in 2007?
Give a very brief answer. -6.39e+09. What is the difference between the Taxes (in constant 2015 US$) in Portugal in 2003 and the Taxes (in constant 2015 US$) in Serbia in 2007?
Ensure brevity in your answer.  1.39e+1. What is the difference between the Taxes (in constant 2015 US$) in Namibia in 2004 and the Taxes (in constant 2015 US$) in Nicaragua in 2005?
Keep it short and to the point. -3.07e+07. What is the difference between the Taxes (in constant 2015 US$) of Namibia in 2004 and the Taxes (in constant 2015 US$) of Portugal in 2005?
Ensure brevity in your answer.  -2.56e+1. What is the difference between the Taxes (in constant 2015 US$) in Namibia in 2004 and the Taxes (in constant 2015 US$) in Serbia in 2005?
Provide a succinct answer. -3.81e+09. What is the difference between the Taxes (in constant 2015 US$) in Nicaragua in 2004 and the Taxes (in constant 2015 US$) in Portugal in 2005?
Make the answer very short. -2.57e+1. What is the difference between the Taxes (in constant 2015 US$) in Nicaragua in 2004 and the Taxes (in constant 2015 US$) in Serbia in 2005?
Ensure brevity in your answer.  -3.85e+09. What is the difference between the Taxes (in constant 2015 US$) in Portugal in 2004 and the Taxes (in constant 2015 US$) in Serbia in 2005?
Make the answer very short. 1.94e+1. What is the difference between the Taxes (in constant 2015 US$) in Namibia in 2004 and the Taxes (in constant 2015 US$) in Nicaragua in 2006?
Offer a very short reply. -9.80e+07. What is the difference between the Taxes (in constant 2015 US$) of Namibia in 2004 and the Taxes (in constant 2015 US$) of Portugal in 2006?
Provide a short and direct response. -2.79e+1. What is the difference between the Taxes (in constant 2015 US$) in Namibia in 2004 and the Taxes (in constant 2015 US$) in Serbia in 2006?
Provide a short and direct response. -4.64e+09. What is the difference between the Taxes (in constant 2015 US$) of Nicaragua in 2004 and the Taxes (in constant 2015 US$) of Portugal in 2006?
Make the answer very short. -2.79e+1. What is the difference between the Taxes (in constant 2015 US$) in Nicaragua in 2004 and the Taxes (in constant 2015 US$) in Serbia in 2006?
Provide a succinct answer. -4.69e+09. What is the difference between the Taxes (in constant 2015 US$) in Portugal in 2004 and the Taxes (in constant 2015 US$) in Serbia in 2006?
Offer a terse response. 1.85e+1. What is the difference between the Taxes (in constant 2015 US$) of Namibia in 2004 and the Taxes (in constant 2015 US$) of Nicaragua in 2007?
Your response must be concise. -1.62e+08. What is the difference between the Taxes (in constant 2015 US$) of Namibia in 2004 and the Taxes (in constant 2015 US$) of Portugal in 2007?
Your answer should be very brief. -3.13e+1. What is the difference between the Taxes (in constant 2015 US$) in Namibia in 2004 and the Taxes (in constant 2015 US$) in Serbia in 2007?
Offer a terse response. -6.30e+09. What is the difference between the Taxes (in constant 2015 US$) in Nicaragua in 2004 and the Taxes (in constant 2015 US$) in Portugal in 2007?
Make the answer very short. -3.14e+1. What is the difference between the Taxes (in constant 2015 US$) in Nicaragua in 2004 and the Taxes (in constant 2015 US$) in Serbia in 2007?
Offer a terse response. -6.35e+09. What is the difference between the Taxes (in constant 2015 US$) in Portugal in 2004 and the Taxes (in constant 2015 US$) in Serbia in 2007?
Ensure brevity in your answer.  1.69e+1. What is the difference between the Taxes (in constant 2015 US$) in Namibia in 2005 and the Taxes (in constant 2015 US$) in Nicaragua in 2006?
Your response must be concise. -3.26e+07. What is the difference between the Taxes (in constant 2015 US$) of Namibia in 2005 and the Taxes (in constant 2015 US$) of Portugal in 2006?
Provide a succinct answer. -2.78e+1. What is the difference between the Taxes (in constant 2015 US$) of Namibia in 2005 and the Taxes (in constant 2015 US$) of Serbia in 2006?
Provide a succinct answer. -4.58e+09. What is the difference between the Taxes (in constant 2015 US$) in Nicaragua in 2005 and the Taxes (in constant 2015 US$) in Portugal in 2006?
Your answer should be compact. -2.79e+1. What is the difference between the Taxes (in constant 2015 US$) in Nicaragua in 2005 and the Taxes (in constant 2015 US$) in Serbia in 2006?
Provide a short and direct response. -4.61e+09. What is the difference between the Taxes (in constant 2015 US$) of Portugal in 2005 and the Taxes (in constant 2015 US$) of Serbia in 2006?
Provide a succinct answer. 2.10e+1. What is the difference between the Taxes (in constant 2015 US$) of Namibia in 2005 and the Taxes (in constant 2015 US$) of Nicaragua in 2007?
Provide a succinct answer. -9.65e+07. What is the difference between the Taxes (in constant 2015 US$) of Namibia in 2005 and the Taxes (in constant 2015 US$) of Portugal in 2007?
Provide a short and direct response. -3.13e+1. What is the difference between the Taxes (in constant 2015 US$) in Namibia in 2005 and the Taxes (in constant 2015 US$) in Serbia in 2007?
Make the answer very short. -6.24e+09. What is the difference between the Taxes (in constant 2015 US$) of Nicaragua in 2005 and the Taxes (in constant 2015 US$) of Portugal in 2007?
Provide a short and direct response. -3.13e+1. What is the difference between the Taxes (in constant 2015 US$) of Nicaragua in 2005 and the Taxes (in constant 2015 US$) of Serbia in 2007?
Offer a terse response. -6.27e+09. What is the difference between the Taxes (in constant 2015 US$) in Portugal in 2005 and the Taxes (in constant 2015 US$) in Serbia in 2007?
Your answer should be very brief. 1.93e+1. What is the difference between the Taxes (in constant 2015 US$) of Namibia in 2006 and the Taxes (in constant 2015 US$) of Nicaragua in 2007?
Make the answer very short. -9.36e+07. What is the difference between the Taxes (in constant 2015 US$) of Namibia in 2006 and the Taxes (in constant 2015 US$) of Portugal in 2007?
Offer a very short reply. -3.13e+1. What is the difference between the Taxes (in constant 2015 US$) in Namibia in 2006 and the Taxes (in constant 2015 US$) in Serbia in 2007?
Make the answer very short. -6.23e+09. What is the difference between the Taxes (in constant 2015 US$) of Nicaragua in 2006 and the Taxes (in constant 2015 US$) of Portugal in 2007?
Provide a short and direct response. -3.12e+1. What is the difference between the Taxes (in constant 2015 US$) in Nicaragua in 2006 and the Taxes (in constant 2015 US$) in Serbia in 2007?
Offer a very short reply. -6.20e+09. What is the difference between the Taxes (in constant 2015 US$) of Portugal in 2006 and the Taxes (in constant 2015 US$) of Serbia in 2007?
Your response must be concise. 2.16e+1. What is the average Taxes (in constant 2015 US$) of Namibia per year?
Your answer should be compact. 4.55e+08. What is the average Taxes (in constant 2015 US$) in Nicaragua per year?
Offer a terse response. 5.19e+08. What is the average Taxes (in constant 2015 US$) of Portugal per year?
Keep it short and to the point. 2.22e+1. What is the average Taxes (in constant 2015 US$) of Serbia per year?
Provide a short and direct response. 3.46e+09. In the year 2000, what is the difference between the Taxes (in constant 2015 US$) of Namibia and Taxes (in constant 2015 US$) of Nicaragua?
Provide a succinct answer. -9.58e+07. In the year 2000, what is the difference between the Taxes (in constant 2015 US$) in Namibia and Taxes (in constant 2015 US$) in Portugal?
Keep it short and to the point. -1.43e+1. In the year 2000, what is the difference between the Taxes (in constant 2015 US$) in Namibia and Taxes (in constant 2015 US$) in Serbia?
Keep it short and to the point. -1.76e+08. In the year 2000, what is the difference between the Taxes (in constant 2015 US$) of Nicaragua and Taxes (in constant 2015 US$) of Portugal?
Keep it short and to the point. -1.42e+1. In the year 2000, what is the difference between the Taxes (in constant 2015 US$) of Nicaragua and Taxes (in constant 2015 US$) of Serbia?
Your response must be concise. -8.00e+07. In the year 2000, what is the difference between the Taxes (in constant 2015 US$) of Portugal and Taxes (in constant 2015 US$) of Serbia?
Offer a very short reply. 1.41e+1. In the year 2001, what is the difference between the Taxes (in constant 2015 US$) in Namibia and Taxes (in constant 2015 US$) in Nicaragua?
Your response must be concise. -1.46e+08. In the year 2001, what is the difference between the Taxes (in constant 2015 US$) in Namibia and Taxes (in constant 2015 US$) in Portugal?
Offer a very short reply. -1.47e+1. In the year 2001, what is the difference between the Taxes (in constant 2015 US$) of Namibia and Taxes (in constant 2015 US$) of Serbia?
Your answer should be very brief. -1.05e+09. In the year 2001, what is the difference between the Taxes (in constant 2015 US$) of Nicaragua and Taxes (in constant 2015 US$) of Portugal?
Offer a terse response. -1.45e+1. In the year 2001, what is the difference between the Taxes (in constant 2015 US$) of Nicaragua and Taxes (in constant 2015 US$) of Serbia?
Offer a terse response. -9.08e+08. In the year 2001, what is the difference between the Taxes (in constant 2015 US$) of Portugal and Taxes (in constant 2015 US$) of Serbia?
Provide a short and direct response. 1.36e+1. In the year 2002, what is the difference between the Taxes (in constant 2015 US$) in Namibia and Taxes (in constant 2015 US$) in Nicaragua?
Your response must be concise. -1.35e+08. In the year 2002, what is the difference between the Taxes (in constant 2015 US$) in Namibia and Taxes (in constant 2015 US$) in Portugal?
Offer a terse response. -1.65e+1. In the year 2002, what is the difference between the Taxes (in constant 2015 US$) in Namibia and Taxes (in constant 2015 US$) in Serbia?
Your answer should be very brief. -2.01e+09. In the year 2002, what is the difference between the Taxes (in constant 2015 US$) in Nicaragua and Taxes (in constant 2015 US$) in Portugal?
Provide a short and direct response. -1.64e+1. In the year 2002, what is the difference between the Taxes (in constant 2015 US$) of Nicaragua and Taxes (in constant 2015 US$) of Serbia?
Ensure brevity in your answer.  -1.87e+09. In the year 2002, what is the difference between the Taxes (in constant 2015 US$) in Portugal and Taxes (in constant 2015 US$) in Serbia?
Keep it short and to the point. 1.45e+1. In the year 2003, what is the difference between the Taxes (in constant 2015 US$) in Namibia and Taxes (in constant 2015 US$) in Nicaragua?
Keep it short and to the point. -1.23e+08. In the year 2003, what is the difference between the Taxes (in constant 2015 US$) in Namibia and Taxes (in constant 2015 US$) in Portugal?
Ensure brevity in your answer.  -2.04e+1. In the year 2003, what is the difference between the Taxes (in constant 2015 US$) of Namibia and Taxes (in constant 2015 US$) of Serbia?
Make the answer very short. -2.92e+09. In the year 2003, what is the difference between the Taxes (in constant 2015 US$) of Nicaragua and Taxes (in constant 2015 US$) of Portugal?
Make the answer very short. -2.02e+1. In the year 2003, what is the difference between the Taxes (in constant 2015 US$) of Nicaragua and Taxes (in constant 2015 US$) of Serbia?
Make the answer very short. -2.80e+09. In the year 2003, what is the difference between the Taxes (in constant 2015 US$) in Portugal and Taxes (in constant 2015 US$) in Serbia?
Provide a short and direct response. 1.74e+1. In the year 2004, what is the difference between the Taxes (in constant 2015 US$) of Namibia and Taxes (in constant 2015 US$) of Nicaragua?
Ensure brevity in your answer.  4.55e+07. In the year 2004, what is the difference between the Taxes (in constant 2015 US$) in Namibia and Taxes (in constant 2015 US$) in Portugal?
Your response must be concise. -2.32e+1. In the year 2004, what is the difference between the Taxes (in constant 2015 US$) of Namibia and Taxes (in constant 2015 US$) of Serbia?
Give a very brief answer. -3.40e+09. In the year 2004, what is the difference between the Taxes (in constant 2015 US$) in Nicaragua and Taxes (in constant 2015 US$) in Portugal?
Offer a terse response. -2.32e+1. In the year 2004, what is the difference between the Taxes (in constant 2015 US$) in Nicaragua and Taxes (in constant 2015 US$) in Serbia?
Make the answer very short. -3.45e+09. In the year 2004, what is the difference between the Taxes (in constant 2015 US$) of Portugal and Taxes (in constant 2015 US$) of Serbia?
Keep it short and to the point. 1.98e+1. In the year 2005, what is the difference between the Taxes (in constant 2015 US$) of Namibia and Taxes (in constant 2015 US$) of Nicaragua?
Provide a succinct answer. 3.47e+07. In the year 2005, what is the difference between the Taxes (in constant 2015 US$) in Namibia and Taxes (in constant 2015 US$) in Portugal?
Your answer should be compact. -2.56e+1. In the year 2005, what is the difference between the Taxes (in constant 2015 US$) of Namibia and Taxes (in constant 2015 US$) of Serbia?
Your answer should be very brief. -3.74e+09. In the year 2005, what is the difference between the Taxes (in constant 2015 US$) in Nicaragua and Taxes (in constant 2015 US$) in Portugal?
Make the answer very short. -2.56e+1. In the year 2005, what is the difference between the Taxes (in constant 2015 US$) in Nicaragua and Taxes (in constant 2015 US$) in Serbia?
Provide a succinct answer. -3.77e+09. In the year 2005, what is the difference between the Taxes (in constant 2015 US$) in Portugal and Taxes (in constant 2015 US$) in Serbia?
Keep it short and to the point. 2.18e+1. In the year 2006, what is the difference between the Taxes (in constant 2015 US$) of Namibia and Taxes (in constant 2015 US$) of Nicaragua?
Your response must be concise. -2.98e+07. In the year 2006, what is the difference between the Taxes (in constant 2015 US$) of Namibia and Taxes (in constant 2015 US$) of Portugal?
Provide a succinct answer. -2.78e+1. In the year 2006, what is the difference between the Taxes (in constant 2015 US$) in Namibia and Taxes (in constant 2015 US$) in Serbia?
Offer a terse response. -4.57e+09. In the year 2006, what is the difference between the Taxes (in constant 2015 US$) in Nicaragua and Taxes (in constant 2015 US$) in Portugal?
Your response must be concise. -2.78e+1. In the year 2006, what is the difference between the Taxes (in constant 2015 US$) of Nicaragua and Taxes (in constant 2015 US$) of Serbia?
Keep it short and to the point. -4.54e+09. In the year 2006, what is the difference between the Taxes (in constant 2015 US$) in Portugal and Taxes (in constant 2015 US$) in Serbia?
Your answer should be very brief. 2.33e+1. In the year 2007, what is the difference between the Taxes (in constant 2015 US$) in Namibia and Taxes (in constant 2015 US$) in Nicaragua?
Your response must be concise. -6.22e+07. In the year 2007, what is the difference between the Taxes (in constant 2015 US$) of Namibia and Taxes (in constant 2015 US$) of Portugal?
Make the answer very short. -3.12e+1. In the year 2007, what is the difference between the Taxes (in constant 2015 US$) of Namibia and Taxes (in constant 2015 US$) of Serbia?
Your answer should be very brief. -6.20e+09. In the year 2007, what is the difference between the Taxes (in constant 2015 US$) of Nicaragua and Taxes (in constant 2015 US$) of Portugal?
Ensure brevity in your answer.  -3.12e+1. In the year 2007, what is the difference between the Taxes (in constant 2015 US$) of Nicaragua and Taxes (in constant 2015 US$) of Serbia?
Provide a succinct answer. -6.14e+09. In the year 2007, what is the difference between the Taxes (in constant 2015 US$) in Portugal and Taxes (in constant 2015 US$) in Serbia?
Provide a short and direct response. 2.50e+1. What is the ratio of the Taxes (in constant 2015 US$) in Namibia in 2000 to that in 2001?
Your answer should be very brief. 1.28. What is the ratio of the Taxes (in constant 2015 US$) of Nicaragua in 2000 to that in 2001?
Provide a succinct answer. 1.06. What is the ratio of the Taxes (in constant 2015 US$) in Portugal in 2000 to that in 2001?
Provide a short and direct response. 0.98. What is the ratio of the Taxes (in constant 2015 US$) of Serbia in 2000 to that in 2001?
Give a very brief answer. 0.4. What is the ratio of the Taxes (in constant 2015 US$) in Namibia in 2000 to that in 2002?
Provide a short and direct response. 1.21. What is the ratio of the Taxes (in constant 2015 US$) of Nicaragua in 2000 to that in 2002?
Offer a very short reply. 1.05. What is the ratio of the Taxes (in constant 2015 US$) in Portugal in 2000 to that in 2002?
Your response must be concise. 0.87. What is the ratio of the Taxes (in constant 2015 US$) of Serbia in 2000 to that in 2002?
Your answer should be very brief. 0.23. What is the ratio of the Taxes (in constant 2015 US$) in Namibia in 2000 to that in 2003?
Your response must be concise. 1.05. What is the ratio of the Taxes (in constant 2015 US$) in Nicaragua in 2000 to that in 2003?
Make the answer very short. 0.98. What is the ratio of the Taxes (in constant 2015 US$) of Portugal in 2000 to that in 2003?
Keep it short and to the point. 0.71. What is the ratio of the Taxes (in constant 2015 US$) of Serbia in 2000 to that in 2003?
Keep it short and to the point. 0.16. What is the ratio of the Taxes (in constant 2015 US$) of Namibia in 2000 to that in 2004?
Provide a short and direct response. 0.64. What is the ratio of the Taxes (in constant 2015 US$) of Nicaragua in 2000 to that in 2004?
Your answer should be very brief. 0.9. What is the ratio of the Taxes (in constant 2015 US$) in Portugal in 2000 to that in 2004?
Provide a short and direct response. 0.62. What is the ratio of the Taxes (in constant 2015 US$) of Serbia in 2000 to that in 2004?
Make the answer very short. 0.13. What is the ratio of the Taxes (in constant 2015 US$) in Namibia in 2000 to that in 2005?
Provide a succinct answer. 0.57. What is the ratio of the Taxes (in constant 2015 US$) of Nicaragua in 2000 to that in 2005?
Your answer should be compact. 0.78. What is the ratio of the Taxes (in constant 2015 US$) in Portugal in 2000 to that in 2005?
Your answer should be very brief. 0.56. What is the ratio of the Taxes (in constant 2015 US$) of Serbia in 2000 to that in 2005?
Provide a short and direct response. 0.12. What is the ratio of the Taxes (in constant 2015 US$) in Namibia in 2000 to that in 2006?
Give a very brief answer. 0.57. What is the ratio of the Taxes (in constant 2015 US$) of Nicaragua in 2000 to that in 2006?
Give a very brief answer. 0.69. What is the ratio of the Taxes (in constant 2015 US$) of Portugal in 2000 to that in 2006?
Your answer should be compact. 0.52. What is the ratio of the Taxes (in constant 2015 US$) of Serbia in 2000 to that in 2006?
Your answer should be very brief. 0.1. What is the ratio of the Taxes (in constant 2015 US$) in Namibia in 2000 to that in 2007?
Make the answer very short. 0.54. What is the ratio of the Taxes (in constant 2015 US$) in Nicaragua in 2000 to that in 2007?
Your response must be concise. 0.63. What is the ratio of the Taxes (in constant 2015 US$) in Portugal in 2000 to that in 2007?
Provide a short and direct response. 0.46. What is the ratio of the Taxes (in constant 2015 US$) of Serbia in 2000 to that in 2007?
Keep it short and to the point. 0.08. What is the ratio of the Taxes (in constant 2015 US$) in Namibia in 2001 to that in 2002?
Ensure brevity in your answer.  0.95. What is the ratio of the Taxes (in constant 2015 US$) in Nicaragua in 2001 to that in 2002?
Make the answer very short. 0.99. What is the ratio of the Taxes (in constant 2015 US$) in Portugal in 2001 to that in 2002?
Offer a terse response. 0.89. What is the ratio of the Taxes (in constant 2015 US$) of Serbia in 2001 to that in 2002?
Your answer should be compact. 0.58. What is the ratio of the Taxes (in constant 2015 US$) of Namibia in 2001 to that in 2003?
Your answer should be compact. 0.83. What is the ratio of the Taxes (in constant 2015 US$) of Nicaragua in 2001 to that in 2003?
Your response must be concise. 0.92. What is the ratio of the Taxes (in constant 2015 US$) of Portugal in 2001 to that in 2003?
Your response must be concise. 0.72. What is the ratio of the Taxes (in constant 2015 US$) of Serbia in 2001 to that in 2003?
Your answer should be very brief. 0.41. What is the ratio of the Taxes (in constant 2015 US$) of Namibia in 2001 to that in 2004?
Your response must be concise. 0.5. What is the ratio of the Taxes (in constant 2015 US$) of Nicaragua in 2001 to that in 2004?
Provide a succinct answer. 0.84. What is the ratio of the Taxes (in constant 2015 US$) of Portugal in 2001 to that in 2004?
Provide a succinct answer. 0.63. What is the ratio of the Taxes (in constant 2015 US$) of Serbia in 2001 to that in 2004?
Your response must be concise. 0.34. What is the ratio of the Taxes (in constant 2015 US$) of Namibia in 2001 to that in 2005?
Give a very brief answer. 0.45. What is the ratio of the Taxes (in constant 2015 US$) of Nicaragua in 2001 to that in 2005?
Give a very brief answer. 0.73. What is the ratio of the Taxes (in constant 2015 US$) of Portugal in 2001 to that in 2005?
Give a very brief answer. 0.57. What is the ratio of the Taxes (in constant 2015 US$) of Serbia in 2001 to that in 2005?
Provide a short and direct response. 0.31. What is the ratio of the Taxes (in constant 2015 US$) in Namibia in 2001 to that in 2006?
Your answer should be very brief. 0.45. What is the ratio of the Taxes (in constant 2015 US$) in Nicaragua in 2001 to that in 2006?
Offer a very short reply. 0.65. What is the ratio of the Taxes (in constant 2015 US$) of Portugal in 2001 to that in 2006?
Give a very brief answer. 0.52. What is the ratio of the Taxes (in constant 2015 US$) in Serbia in 2001 to that in 2006?
Your response must be concise. 0.26. What is the ratio of the Taxes (in constant 2015 US$) in Namibia in 2001 to that in 2007?
Give a very brief answer. 0.43. What is the ratio of the Taxes (in constant 2015 US$) in Nicaragua in 2001 to that in 2007?
Your response must be concise. 0.6. What is the ratio of the Taxes (in constant 2015 US$) in Portugal in 2001 to that in 2007?
Make the answer very short. 0.47. What is the ratio of the Taxes (in constant 2015 US$) of Serbia in 2001 to that in 2007?
Provide a short and direct response. 0.19. What is the ratio of the Taxes (in constant 2015 US$) in Namibia in 2002 to that in 2003?
Ensure brevity in your answer.  0.87. What is the ratio of the Taxes (in constant 2015 US$) in Nicaragua in 2002 to that in 2003?
Make the answer very short. 0.93. What is the ratio of the Taxes (in constant 2015 US$) of Portugal in 2002 to that in 2003?
Your response must be concise. 0.81. What is the ratio of the Taxes (in constant 2015 US$) in Serbia in 2002 to that in 2003?
Provide a short and direct response. 0.71. What is the ratio of the Taxes (in constant 2015 US$) in Namibia in 2002 to that in 2004?
Make the answer very short. 0.53. What is the ratio of the Taxes (in constant 2015 US$) of Nicaragua in 2002 to that in 2004?
Provide a succinct answer. 0.85. What is the ratio of the Taxes (in constant 2015 US$) in Portugal in 2002 to that in 2004?
Give a very brief answer. 0.71. What is the ratio of the Taxes (in constant 2015 US$) in Serbia in 2002 to that in 2004?
Keep it short and to the point. 0.58. What is the ratio of the Taxes (in constant 2015 US$) of Namibia in 2002 to that in 2005?
Keep it short and to the point. 0.47. What is the ratio of the Taxes (in constant 2015 US$) of Nicaragua in 2002 to that in 2005?
Your answer should be very brief. 0.74. What is the ratio of the Taxes (in constant 2015 US$) of Portugal in 2002 to that in 2005?
Provide a succinct answer. 0.64. What is the ratio of the Taxes (in constant 2015 US$) in Serbia in 2002 to that in 2005?
Make the answer very short. 0.53. What is the ratio of the Taxes (in constant 2015 US$) in Namibia in 2002 to that in 2006?
Provide a succinct answer. 0.47. What is the ratio of the Taxes (in constant 2015 US$) of Nicaragua in 2002 to that in 2006?
Make the answer very short. 0.66. What is the ratio of the Taxes (in constant 2015 US$) in Portugal in 2002 to that in 2006?
Offer a very short reply. 0.59. What is the ratio of the Taxes (in constant 2015 US$) of Serbia in 2002 to that in 2006?
Offer a very short reply. 0.44. What is the ratio of the Taxes (in constant 2015 US$) in Namibia in 2002 to that in 2007?
Make the answer very short. 0.45. What is the ratio of the Taxes (in constant 2015 US$) in Nicaragua in 2002 to that in 2007?
Give a very brief answer. 0.6. What is the ratio of the Taxes (in constant 2015 US$) of Portugal in 2002 to that in 2007?
Make the answer very short. 0.53. What is the ratio of the Taxes (in constant 2015 US$) of Serbia in 2002 to that in 2007?
Provide a succinct answer. 0.34. What is the ratio of the Taxes (in constant 2015 US$) in Namibia in 2003 to that in 2004?
Offer a very short reply. 0.61. What is the ratio of the Taxes (in constant 2015 US$) in Nicaragua in 2003 to that in 2004?
Offer a very short reply. 0.92. What is the ratio of the Taxes (in constant 2015 US$) in Portugal in 2003 to that in 2004?
Your answer should be compact. 0.87. What is the ratio of the Taxes (in constant 2015 US$) in Serbia in 2003 to that in 2004?
Provide a short and direct response. 0.82. What is the ratio of the Taxes (in constant 2015 US$) of Namibia in 2003 to that in 2005?
Offer a very short reply. 0.55. What is the ratio of the Taxes (in constant 2015 US$) in Nicaragua in 2003 to that in 2005?
Your answer should be compact. 0.79. What is the ratio of the Taxes (in constant 2015 US$) of Portugal in 2003 to that in 2005?
Provide a succinct answer. 0.79. What is the ratio of the Taxes (in constant 2015 US$) of Serbia in 2003 to that in 2005?
Offer a very short reply. 0.75. What is the ratio of the Taxes (in constant 2015 US$) in Namibia in 2003 to that in 2006?
Provide a succinct answer. 0.54. What is the ratio of the Taxes (in constant 2015 US$) in Nicaragua in 2003 to that in 2006?
Your response must be concise. 0.71. What is the ratio of the Taxes (in constant 2015 US$) of Portugal in 2003 to that in 2006?
Your answer should be compact. 0.73. What is the ratio of the Taxes (in constant 2015 US$) in Serbia in 2003 to that in 2006?
Give a very brief answer. 0.63. What is the ratio of the Taxes (in constant 2015 US$) in Namibia in 2003 to that in 2007?
Provide a short and direct response. 0.52. What is the ratio of the Taxes (in constant 2015 US$) in Nicaragua in 2003 to that in 2007?
Provide a short and direct response. 0.65. What is the ratio of the Taxes (in constant 2015 US$) of Portugal in 2003 to that in 2007?
Offer a terse response. 0.65. What is the ratio of the Taxes (in constant 2015 US$) of Serbia in 2003 to that in 2007?
Keep it short and to the point. 0.47. What is the ratio of the Taxes (in constant 2015 US$) in Namibia in 2004 to that in 2005?
Make the answer very short. 0.89. What is the ratio of the Taxes (in constant 2015 US$) of Nicaragua in 2004 to that in 2005?
Your answer should be compact. 0.87. What is the ratio of the Taxes (in constant 2015 US$) of Portugal in 2004 to that in 2005?
Provide a short and direct response. 0.91. What is the ratio of the Taxes (in constant 2015 US$) of Serbia in 2004 to that in 2005?
Give a very brief answer. 0.91. What is the ratio of the Taxes (in constant 2015 US$) of Namibia in 2004 to that in 2006?
Ensure brevity in your answer.  0.89. What is the ratio of the Taxes (in constant 2015 US$) in Nicaragua in 2004 to that in 2006?
Your response must be concise. 0.78. What is the ratio of the Taxes (in constant 2015 US$) in Portugal in 2004 to that in 2006?
Provide a succinct answer. 0.83. What is the ratio of the Taxes (in constant 2015 US$) of Serbia in 2004 to that in 2006?
Make the answer very short. 0.76. What is the ratio of the Taxes (in constant 2015 US$) of Namibia in 2004 to that in 2007?
Keep it short and to the point. 0.84. What is the ratio of the Taxes (in constant 2015 US$) in Nicaragua in 2004 to that in 2007?
Your answer should be very brief. 0.71. What is the ratio of the Taxes (in constant 2015 US$) in Portugal in 2004 to that in 2007?
Your answer should be very brief. 0.74. What is the ratio of the Taxes (in constant 2015 US$) in Serbia in 2004 to that in 2007?
Your response must be concise. 0.58. What is the ratio of the Taxes (in constant 2015 US$) in Namibia in 2005 to that in 2006?
Give a very brief answer. 1. What is the ratio of the Taxes (in constant 2015 US$) in Nicaragua in 2005 to that in 2006?
Offer a terse response. 0.89. What is the ratio of the Taxes (in constant 2015 US$) in Portugal in 2005 to that in 2006?
Keep it short and to the point. 0.92. What is the ratio of the Taxes (in constant 2015 US$) in Serbia in 2005 to that in 2006?
Your answer should be compact. 0.84. What is the ratio of the Taxes (in constant 2015 US$) in Namibia in 2005 to that in 2007?
Give a very brief answer. 0.95. What is the ratio of the Taxes (in constant 2015 US$) in Nicaragua in 2005 to that in 2007?
Make the answer very short. 0.81. What is the ratio of the Taxes (in constant 2015 US$) of Portugal in 2005 to that in 2007?
Give a very brief answer. 0.82. What is the ratio of the Taxes (in constant 2015 US$) of Serbia in 2005 to that in 2007?
Keep it short and to the point. 0.64. What is the ratio of the Taxes (in constant 2015 US$) in Namibia in 2006 to that in 2007?
Offer a terse response. 0.95. What is the ratio of the Taxes (in constant 2015 US$) in Nicaragua in 2006 to that in 2007?
Provide a succinct answer. 0.91. What is the ratio of the Taxes (in constant 2015 US$) of Portugal in 2006 to that in 2007?
Ensure brevity in your answer.  0.89. What is the ratio of the Taxes (in constant 2015 US$) of Serbia in 2006 to that in 2007?
Provide a succinct answer. 0.76. What is the difference between the highest and the second highest Taxes (in constant 2015 US$) in Namibia?
Make the answer very short. 3.14e+07. What is the difference between the highest and the second highest Taxes (in constant 2015 US$) of Nicaragua?
Give a very brief answer. 6.38e+07. What is the difference between the highest and the second highest Taxes (in constant 2015 US$) in Portugal?
Your response must be concise. 3.43e+09. What is the difference between the highest and the second highest Taxes (in constant 2015 US$) of Serbia?
Make the answer very short. 1.66e+09. What is the difference between the highest and the lowest Taxes (in constant 2015 US$) of Namibia?
Offer a terse response. 3.68e+08. What is the difference between the highest and the lowest Taxes (in constant 2015 US$) in Nicaragua?
Give a very brief answer. 2.85e+08. What is the difference between the highest and the lowest Taxes (in constant 2015 US$) of Portugal?
Offer a terse response. 1.72e+1. What is the difference between the highest and the lowest Taxes (in constant 2015 US$) of Serbia?
Ensure brevity in your answer.  6.32e+09. 